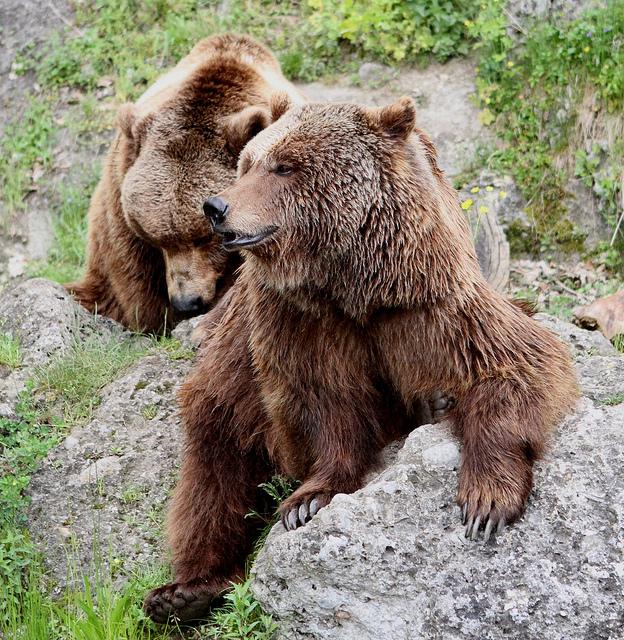Do the bears like each other?
Write a very short answer. Yes. How many bears are on the rock?
Answer briefly. 2. What are they laying atop?
Concise answer only. Rocks. 